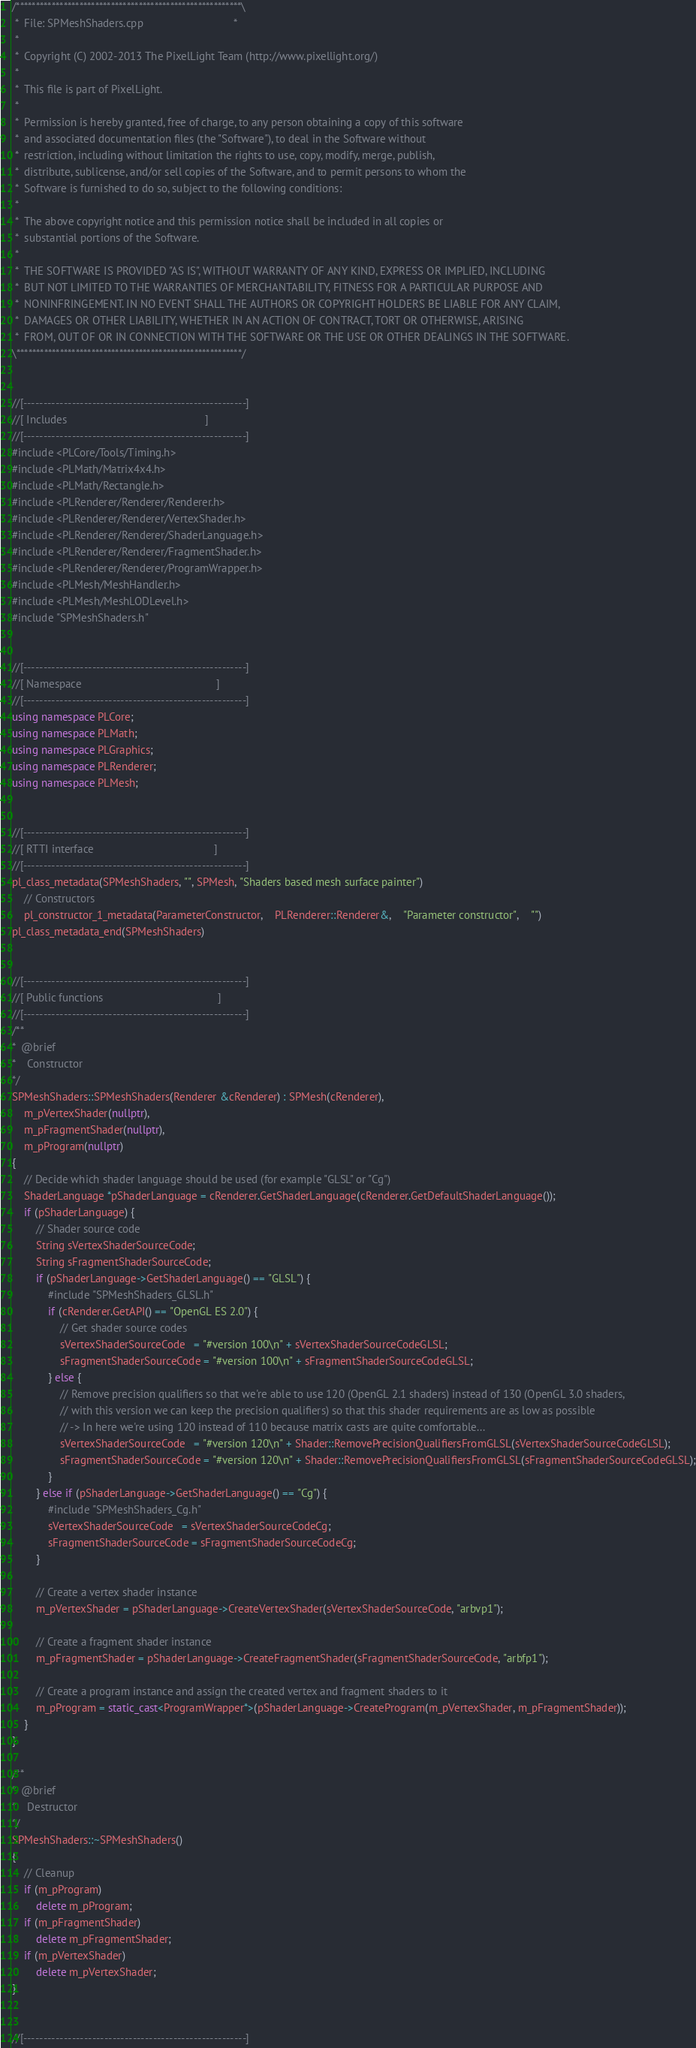<code> <loc_0><loc_0><loc_500><loc_500><_C++_>/*********************************************************\
 *  File: SPMeshShaders.cpp                              *
 *
 *  Copyright (C) 2002-2013 The PixelLight Team (http://www.pixellight.org/)
 *
 *  This file is part of PixelLight.
 *
 *  Permission is hereby granted, free of charge, to any person obtaining a copy of this software
 *  and associated documentation files (the "Software"), to deal in the Software without
 *  restriction, including without limitation the rights to use, copy, modify, merge, publish,
 *  distribute, sublicense, and/or sell copies of the Software, and to permit persons to whom the
 *  Software is furnished to do so, subject to the following conditions:
 *
 *  The above copyright notice and this permission notice shall be included in all copies or
 *  substantial portions of the Software.
 *
 *  THE SOFTWARE IS PROVIDED "AS IS", WITHOUT WARRANTY OF ANY KIND, EXPRESS OR IMPLIED, INCLUDING
 *  BUT NOT LIMITED TO THE WARRANTIES OF MERCHANTABILITY, FITNESS FOR A PARTICULAR PURPOSE AND
 *  NONINFRINGEMENT. IN NO EVENT SHALL THE AUTHORS OR COPYRIGHT HOLDERS BE LIABLE FOR ANY CLAIM,
 *  DAMAGES OR OTHER LIABILITY, WHETHER IN AN ACTION OF CONTRACT, TORT OR OTHERWISE, ARISING
 *  FROM, OUT OF OR IN CONNECTION WITH THE SOFTWARE OR THE USE OR OTHER DEALINGS IN THE SOFTWARE.
\*********************************************************/


//[-------------------------------------------------------]
//[ Includes                                              ]
//[-------------------------------------------------------]
#include <PLCore/Tools/Timing.h>
#include <PLMath/Matrix4x4.h>
#include <PLMath/Rectangle.h>
#include <PLRenderer/Renderer/Renderer.h>
#include <PLRenderer/Renderer/VertexShader.h>
#include <PLRenderer/Renderer/ShaderLanguage.h>
#include <PLRenderer/Renderer/FragmentShader.h>
#include <PLRenderer/Renderer/ProgramWrapper.h>
#include <PLMesh/MeshHandler.h>
#include <PLMesh/MeshLODLevel.h>
#include "SPMeshShaders.h"


//[-------------------------------------------------------]
//[ Namespace                                             ]
//[-------------------------------------------------------]
using namespace PLCore;
using namespace PLMath;
using namespace PLGraphics;
using namespace PLRenderer;
using namespace PLMesh;


//[-------------------------------------------------------]
//[ RTTI interface                                        ]
//[-------------------------------------------------------]
pl_class_metadata(SPMeshShaders, "", SPMesh, "Shaders based mesh surface painter")
	// Constructors
	pl_constructor_1_metadata(ParameterConstructor,	PLRenderer::Renderer&,	"Parameter constructor",	"")
pl_class_metadata_end(SPMeshShaders)


//[-------------------------------------------------------]
//[ Public functions                                      ]
//[-------------------------------------------------------]
/**
*  @brief
*    Constructor
*/
SPMeshShaders::SPMeshShaders(Renderer &cRenderer) : SPMesh(cRenderer),
	m_pVertexShader(nullptr),
	m_pFragmentShader(nullptr),
	m_pProgram(nullptr)
{
	// Decide which shader language should be used (for example "GLSL" or "Cg")
	ShaderLanguage *pShaderLanguage = cRenderer.GetShaderLanguage(cRenderer.GetDefaultShaderLanguage());
	if (pShaderLanguage) {
		// Shader source code
		String sVertexShaderSourceCode;
		String sFragmentShaderSourceCode;
		if (pShaderLanguage->GetShaderLanguage() == "GLSL") {
			#include "SPMeshShaders_GLSL.h"
			if (cRenderer.GetAPI() == "OpenGL ES 2.0") {
				// Get shader source codes
				sVertexShaderSourceCode   = "#version 100\n" + sVertexShaderSourceCodeGLSL;
				sFragmentShaderSourceCode = "#version 100\n" + sFragmentShaderSourceCodeGLSL;
			} else {
				// Remove precision qualifiers so that we're able to use 120 (OpenGL 2.1 shaders) instead of 130 (OpenGL 3.0 shaders,
				// with this version we can keep the precision qualifiers) so that this shader requirements are as low as possible
				// -> In here we're using 120 instead of 110 because matrix casts are quite comfortable...
				sVertexShaderSourceCode   = "#version 120\n" + Shader::RemovePrecisionQualifiersFromGLSL(sVertexShaderSourceCodeGLSL);
				sFragmentShaderSourceCode = "#version 120\n" + Shader::RemovePrecisionQualifiersFromGLSL(sFragmentShaderSourceCodeGLSL);
			}
		} else if (pShaderLanguage->GetShaderLanguage() == "Cg") {
			#include "SPMeshShaders_Cg.h"
			sVertexShaderSourceCode   = sVertexShaderSourceCodeCg;
			sFragmentShaderSourceCode = sFragmentShaderSourceCodeCg;
		}

		// Create a vertex shader instance
		m_pVertexShader = pShaderLanguage->CreateVertexShader(sVertexShaderSourceCode, "arbvp1");

		// Create a fragment shader instance
		m_pFragmentShader = pShaderLanguage->CreateFragmentShader(sFragmentShaderSourceCode, "arbfp1");

		// Create a program instance and assign the created vertex and fragment shaders to it
		m_pProgram = static_cast<ProgramWrapper*>(pShaderLanguage->CreateProgram(m_pVertexShader, m_pFragmentShader));
	}
}

/**
*  @brief
*    Destructor
*/
SPMeshShaders::~SPMeshShaders()
{
	// Cleanup
	if (m_pProgram)
		delete m_pProgram;
	if (m_pFragmentShader)
		delete m_pFragmentShader;
	if (m_pVertexShader)
		delete m_pVertexShader;
}


//[-------------------------------------------------------]</code> 